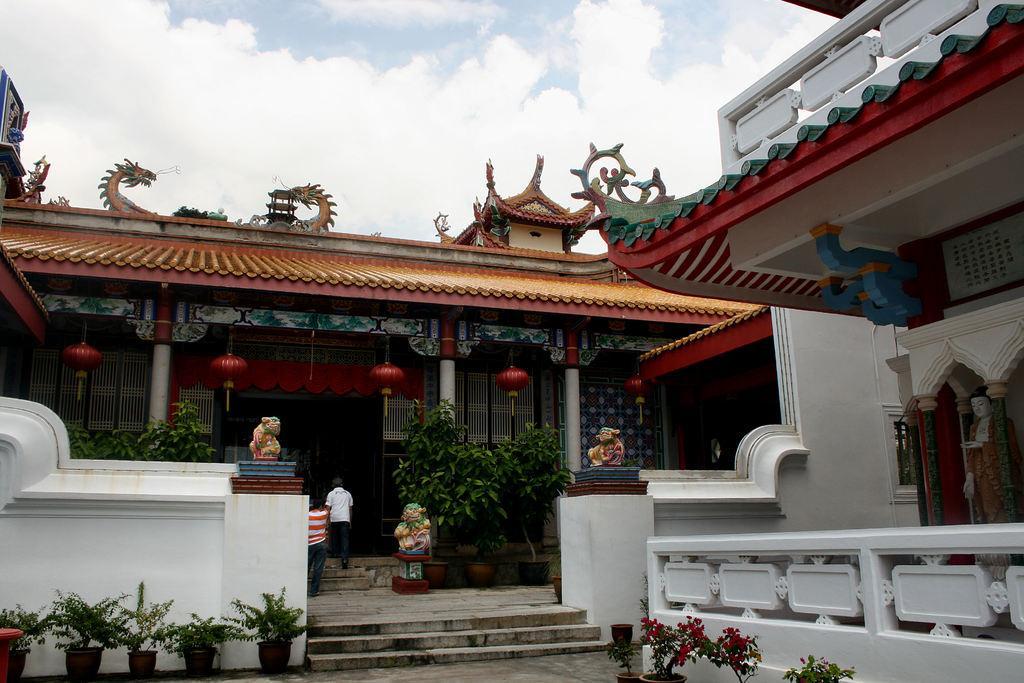Please provide a concise description of this image. In this image I can see houseplants, fence, statues, two persons and buildings. At the top I can see the sky. This image is taken may be during a day. 